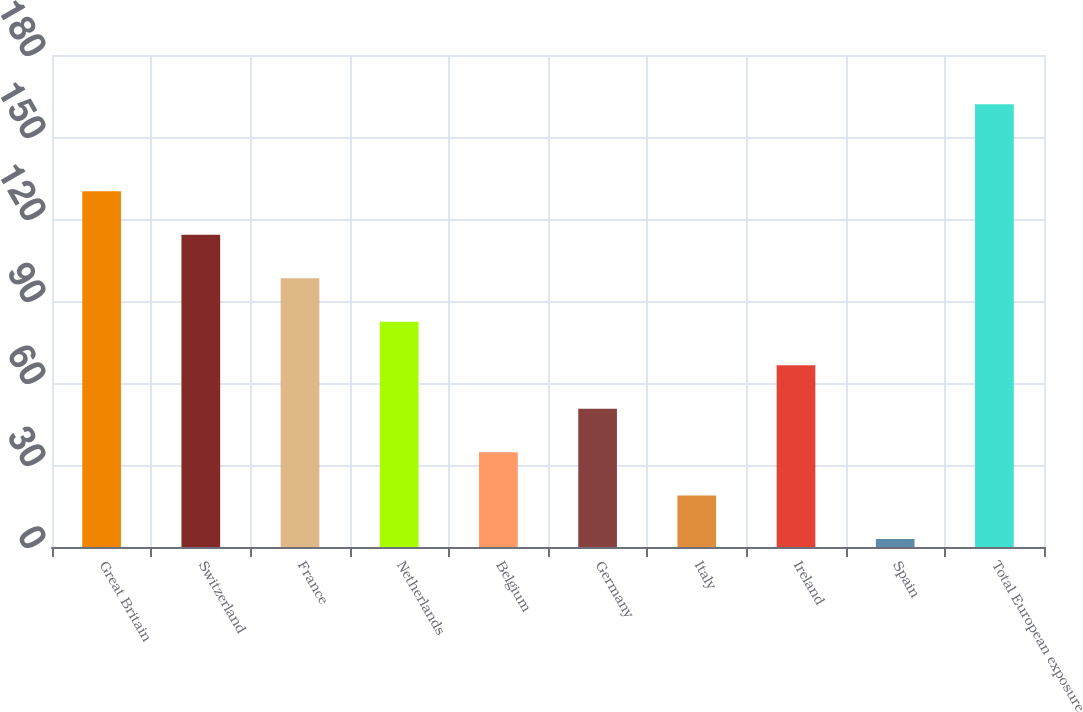<chart> <loc_0><loc_0><loc_500><loc_500><bar_chart><fcel>Great Britain<fcel>Switzerland<fcel>France<fcel>Netherlands<fcel>Belgium<fcel>Germany<fcel>Italy<fcel>Ireland<fcel>Spain<fcel>Total European exposure<nl><fcel>130.17<fcel>114.26<fcel>98.35<fcel>82.44<fcel>34.71<fcel>50.62<fcel>18.8<fcel>66.53<fcel>2.89<fcel>162<nl></chart> 